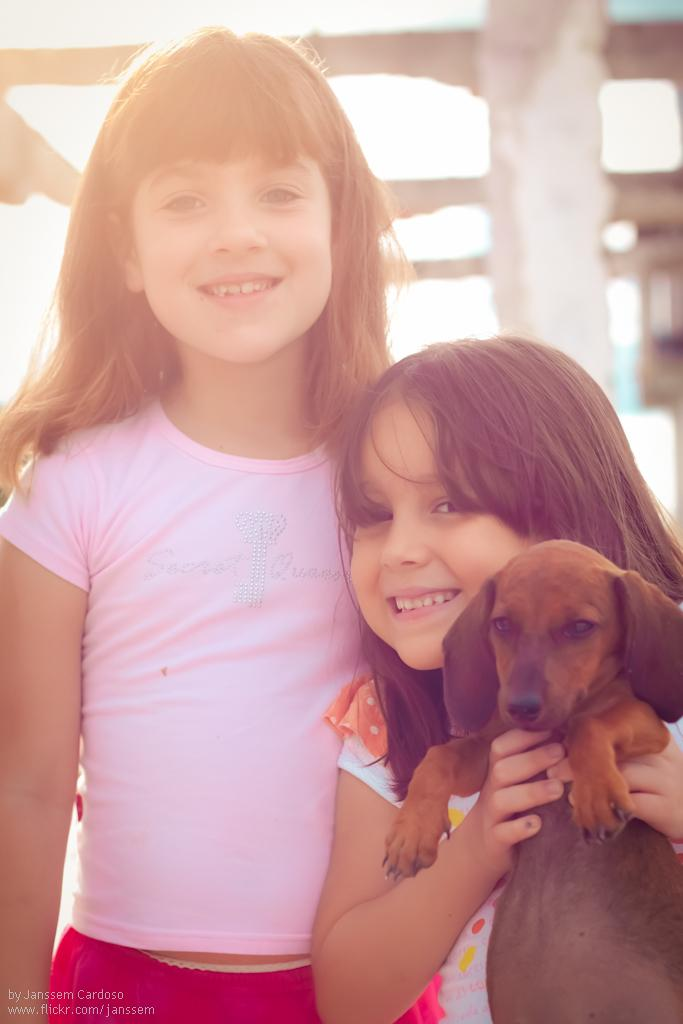How many girls are present in the image? There are two girls in the image. Where are the girls positioned in relation to each other? One girl is on the left side, and the other is on the right side. What is the girl on the right side holding? The girl on the right side is holding a dog in her hands. What direction is the girl on the left side facing, and what is the amount of silver visible in the image? The provided facts do not mention the direction the girl on the left side is facing, nor do they mention any silver in the image. 